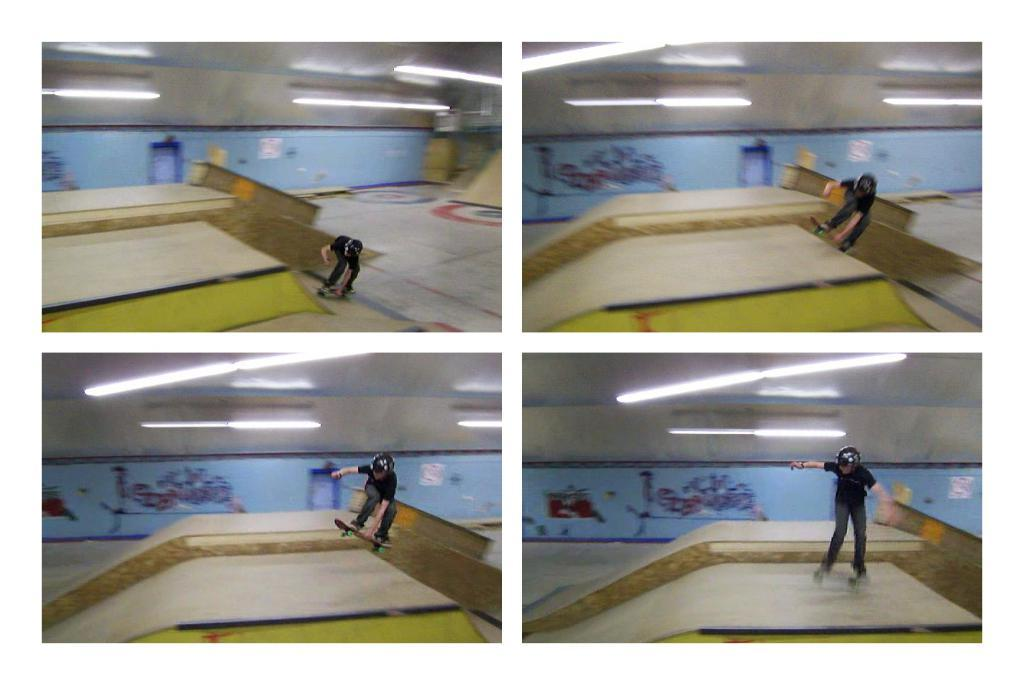What type of artwork is the image? The image is a collage. What activity is the boy in the collage engaged in? The boy is skating in the collage. Where is the skating taking place? The skating is taking place in a skate park. What can be seen at the top of the collage? There are lights visible at the top of the collage. What is painted on the wall in the background of the collage? There is a wall painted in the background of the collage. Can you see the ocean in the background of the collage? No, there is no ocean visible in the background of the collage. How does the boy lift himself off the ground while skating in the collage? The boy does not lift himself off the ground in the collage; he is skating on the ground. 